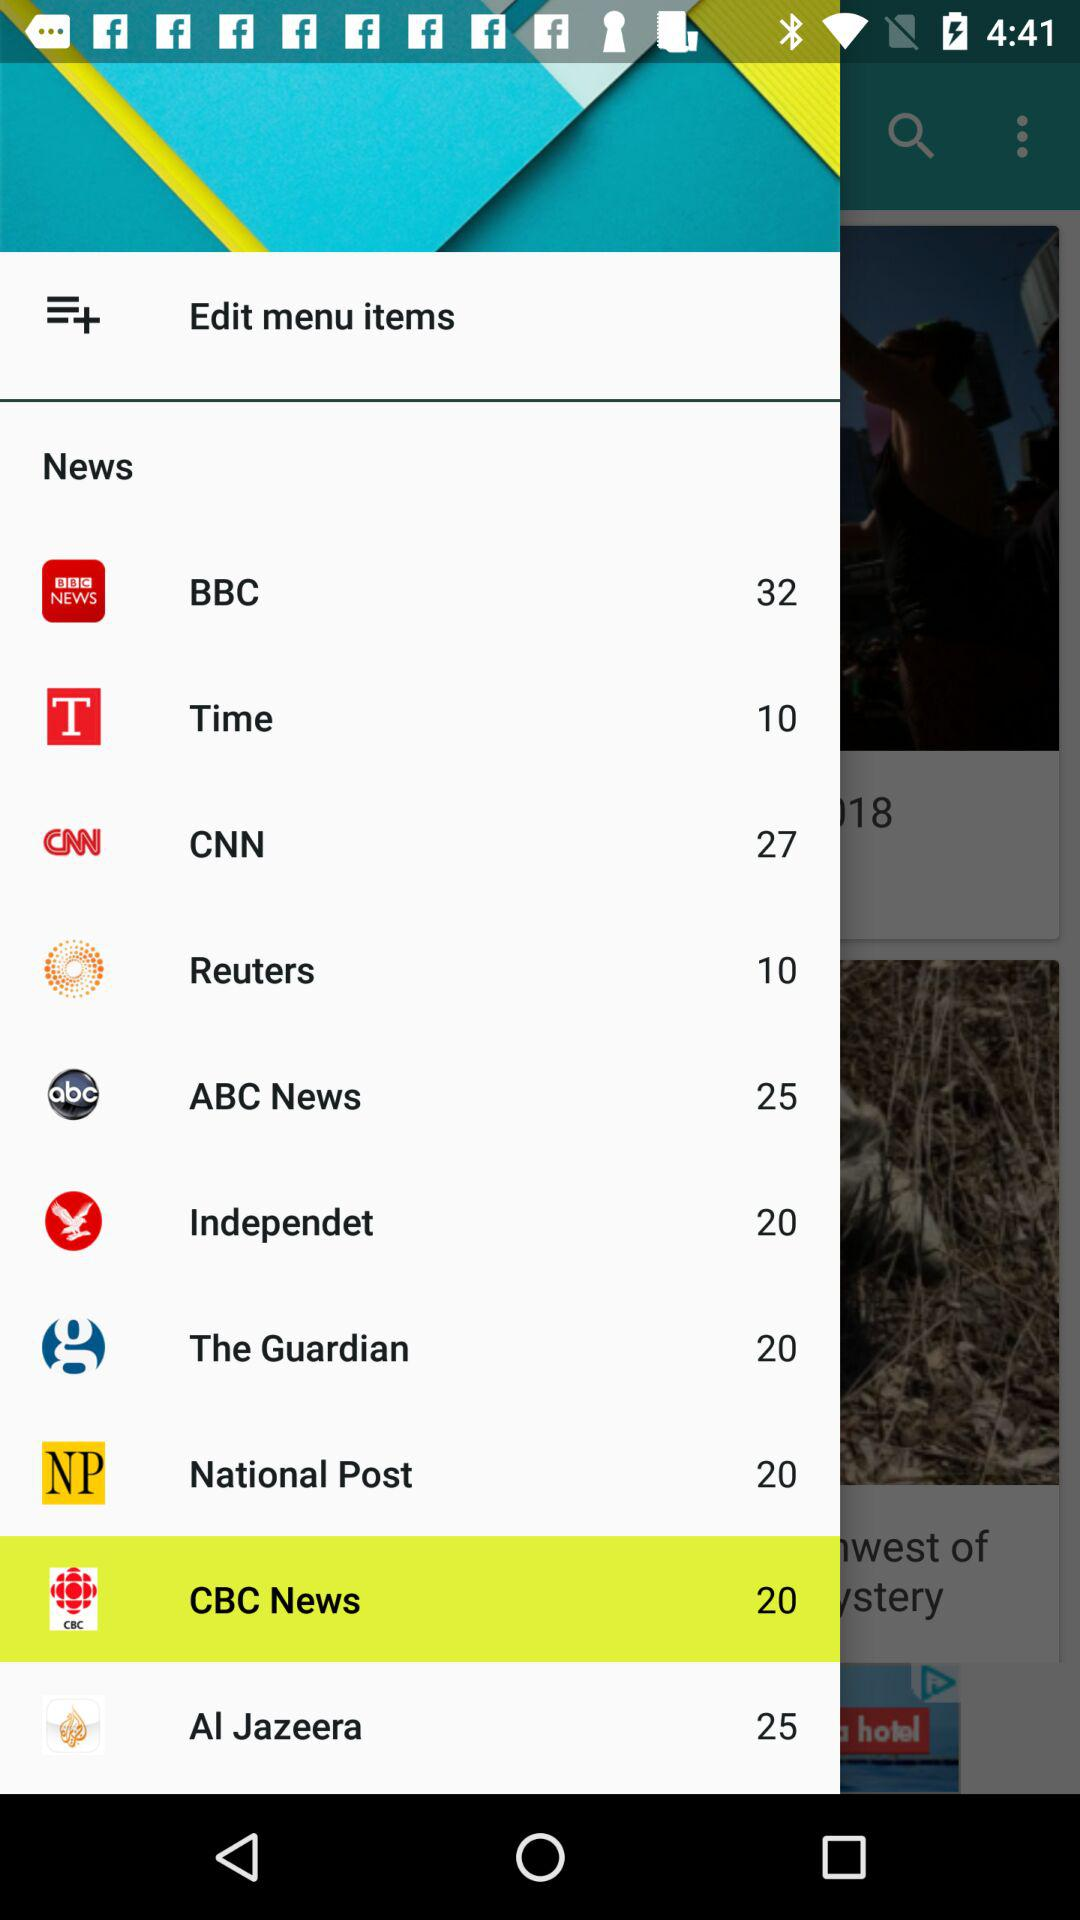What is the selected news channel? The selected news channel is "CBC News". 